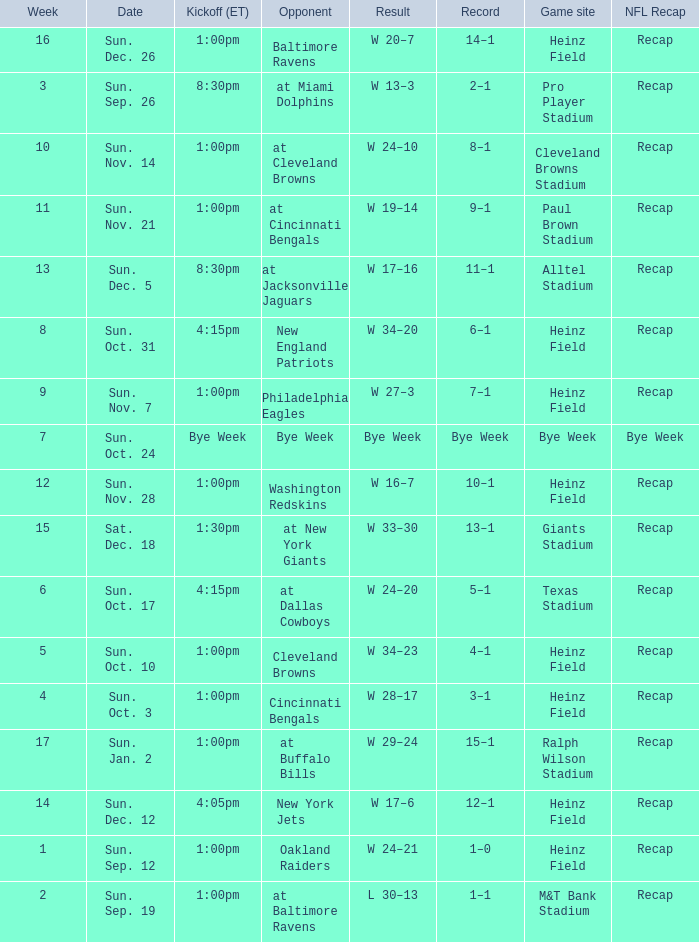Which Kickoff (ET) has a Result of w 34–23? 1:00pm. 